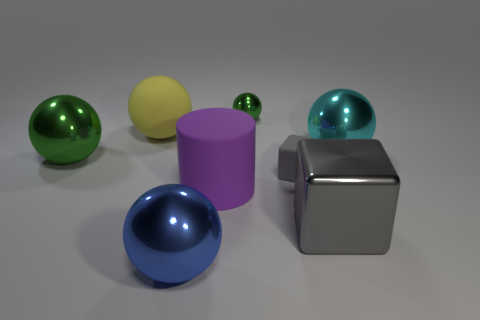Does the small object in front of the large yellow rubber sphere have the same color as the large shiny block in front of the cyan shiny ball?
Your answer should be very brief. Yes. The blue thing that is the same material as the large green object is what shape?
Provide a succinct answer. Sphere. Is the size of the green thing to the right of the yellow ball the same as the large cube?
Give a very brief answer. No. There is a metallic thing that is behind the big sphere right of the large cylinder; what shape is it?
Keep it short and to the point. Sphere. There is a green shiny sphere that is behind the large matte ball that is behind the big purple cylinder; what size is it?
Give a very brief answer. Small. What color is the metallic object that is to the left of the yellow ball?
Your answer should be very brief. Green. What is the size of the blue sphere that is made of the same material as the big cyan ball?
Give a very brief answer. Large. What number of other small gray rubber things are the same shape as the tiny matte object?
Keep it short and to the point. 0. There is a blue sphere that is the same size as the gray shiny thing; what is its material?
Your answer should be compact. Metal. Are there any other blue objects made of the same material as the big blue object?
Offer a terse response. No. 